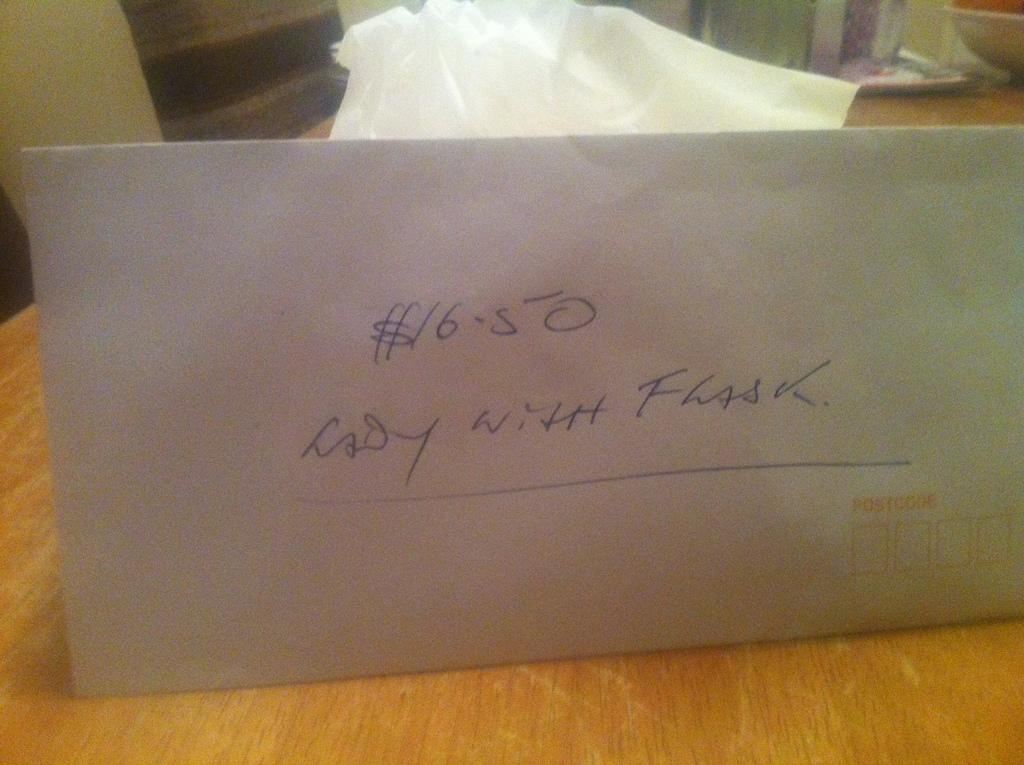<image>
Offer a succinct explanation of the picture presented. A paper envelope that has lady with flask written on the front of it. 